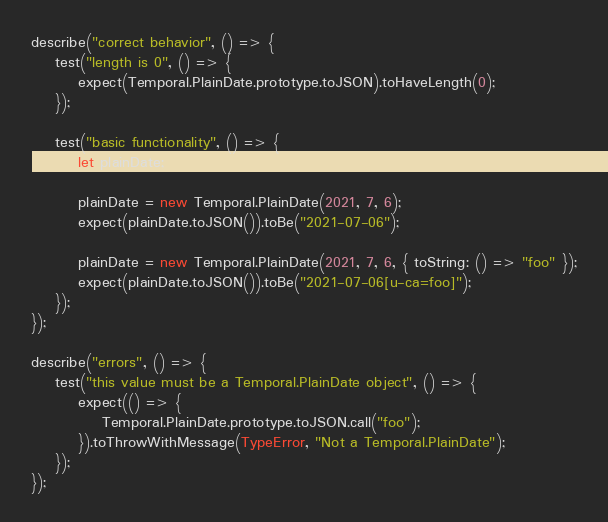<code> <loc_0><loc_0><loc_500><loc_500><_JavaScript_>describe("correct behavior", () => {
    test("length is 0", () => {
        expect(Temporal.PlainDate.prototype.toJSON).toHaveLength(0);
    });

    test("basic functionality", () => {
        let plainDate;

        plainDate = new Temporal.PlainDate(2021, 7, 6);
        expect(plainDate.toJSON()).toBe("2021-07-06");

        plainDate = new Temporal.PlainDate(2021, 7, 6, { toString: () => "foo" });
        expect(plainDate.toJSON()).toBe("2021-07-06[u-ca=foo]");
    });
});

describe("errors", () => {
    test("this value must be a Temporal.PlainDate object", () => {
        expect(() => {
            Temporal.PlainDate.prototype.toJSON.call("foo");
        }).toThrowWithMessage(TypeError, "Not a Temporal.PlainDate");
    });
});
</code> 